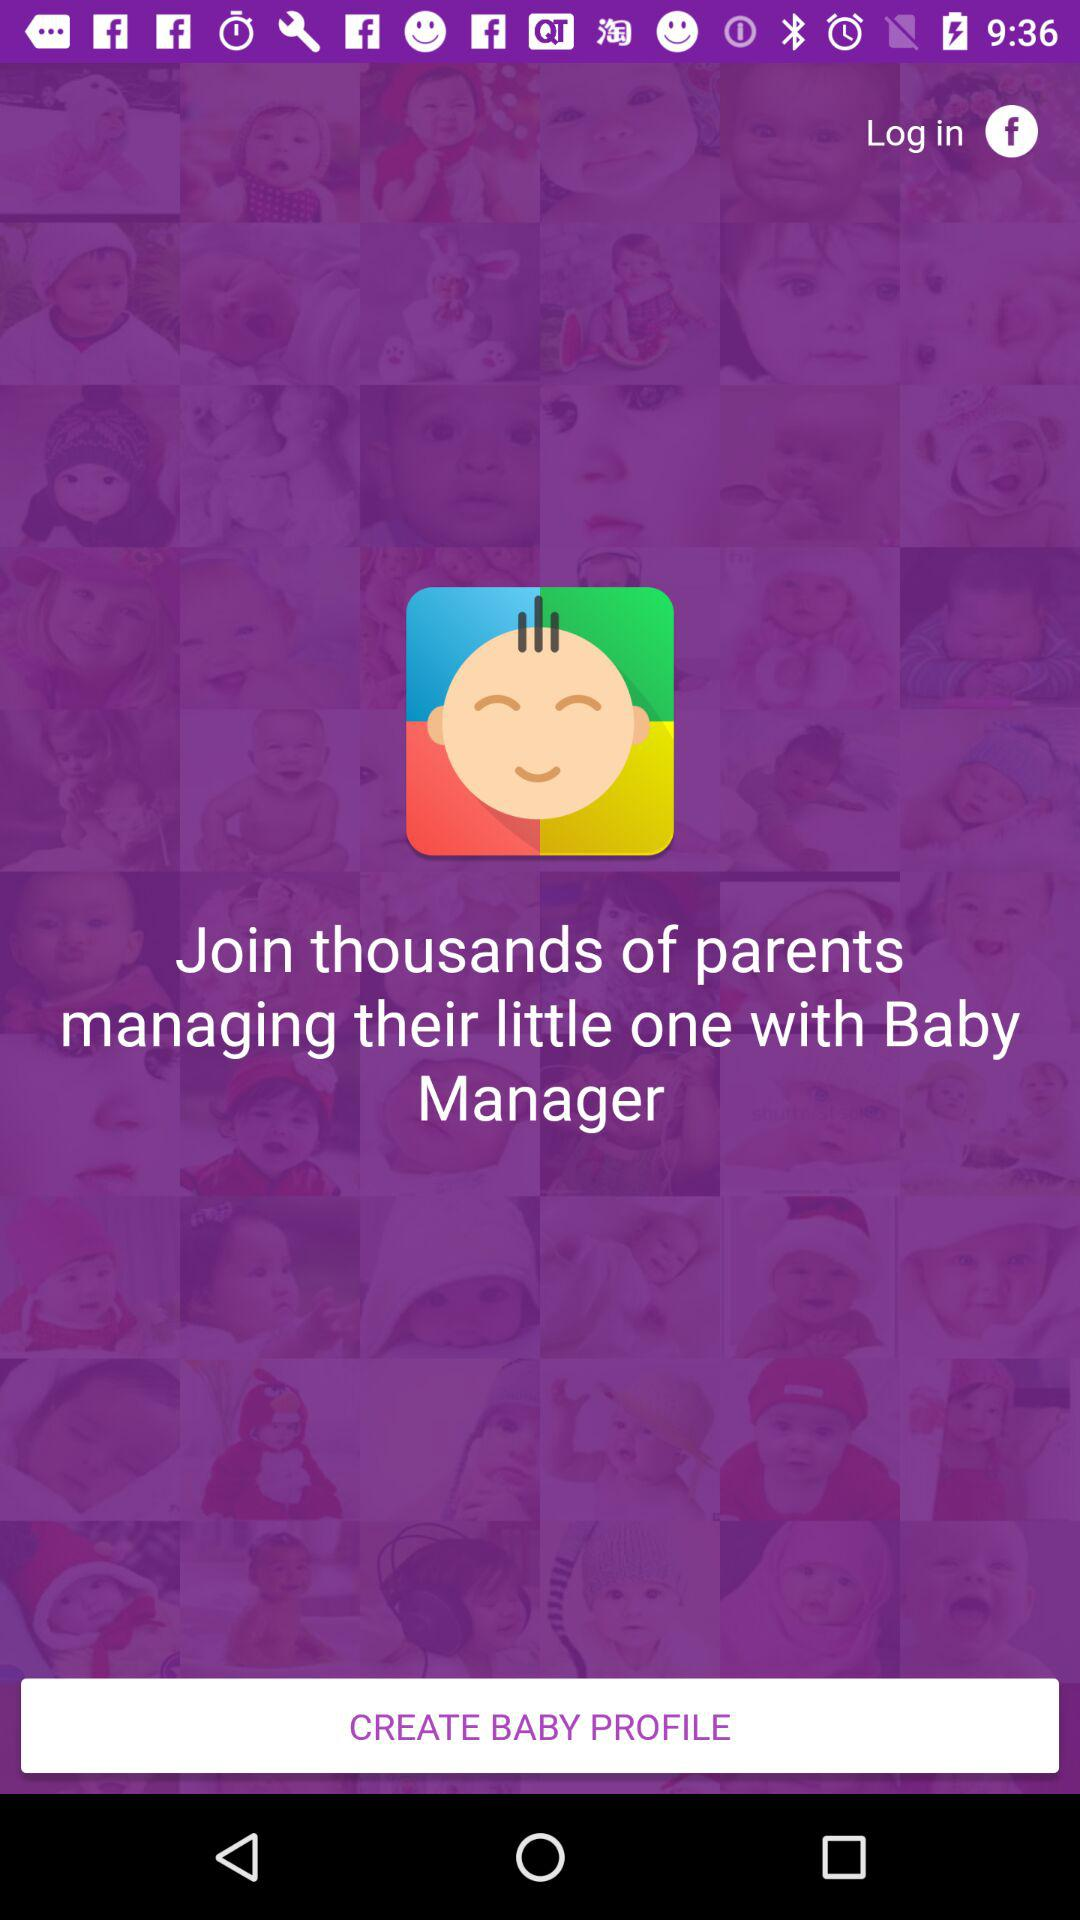Through what application can I log in? You can log in through "Facebook". 